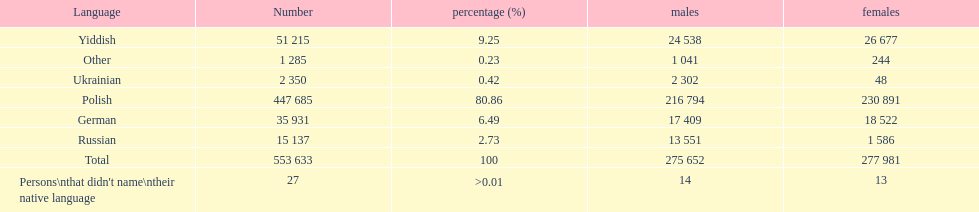How many male and female german speakers are there? 35931. 